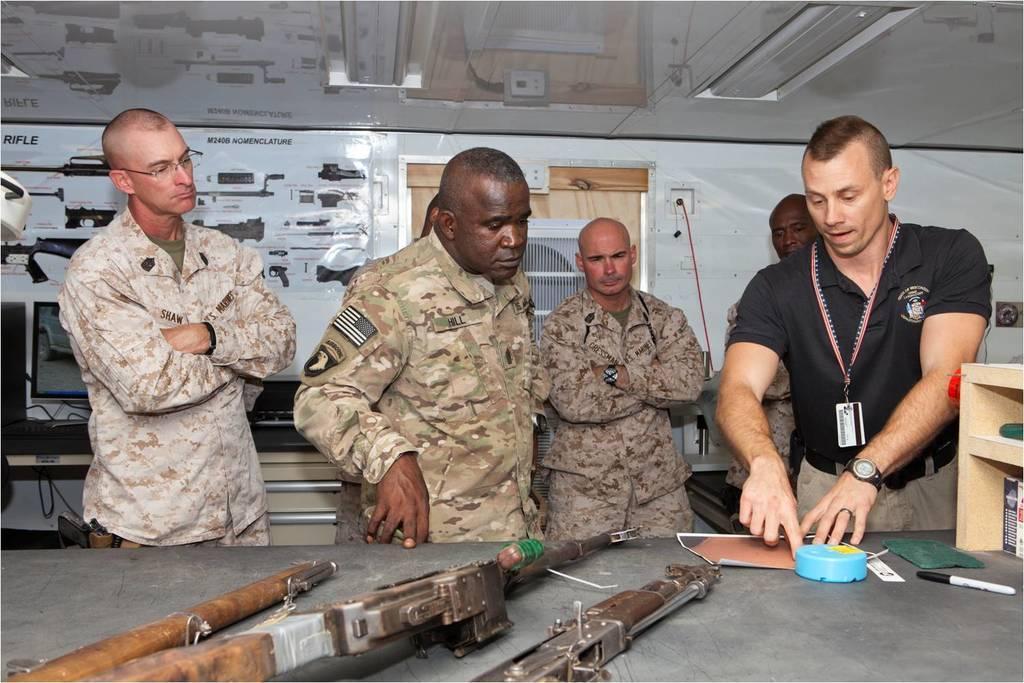In one or two sentences, can you explain what this image depicts? In the center of the image there are military officers. At the right side of the image there is a person wearing a black color t-shirt and a id card. At the background of the image there is a wall. At the bottom of the image there are guns on the table. 